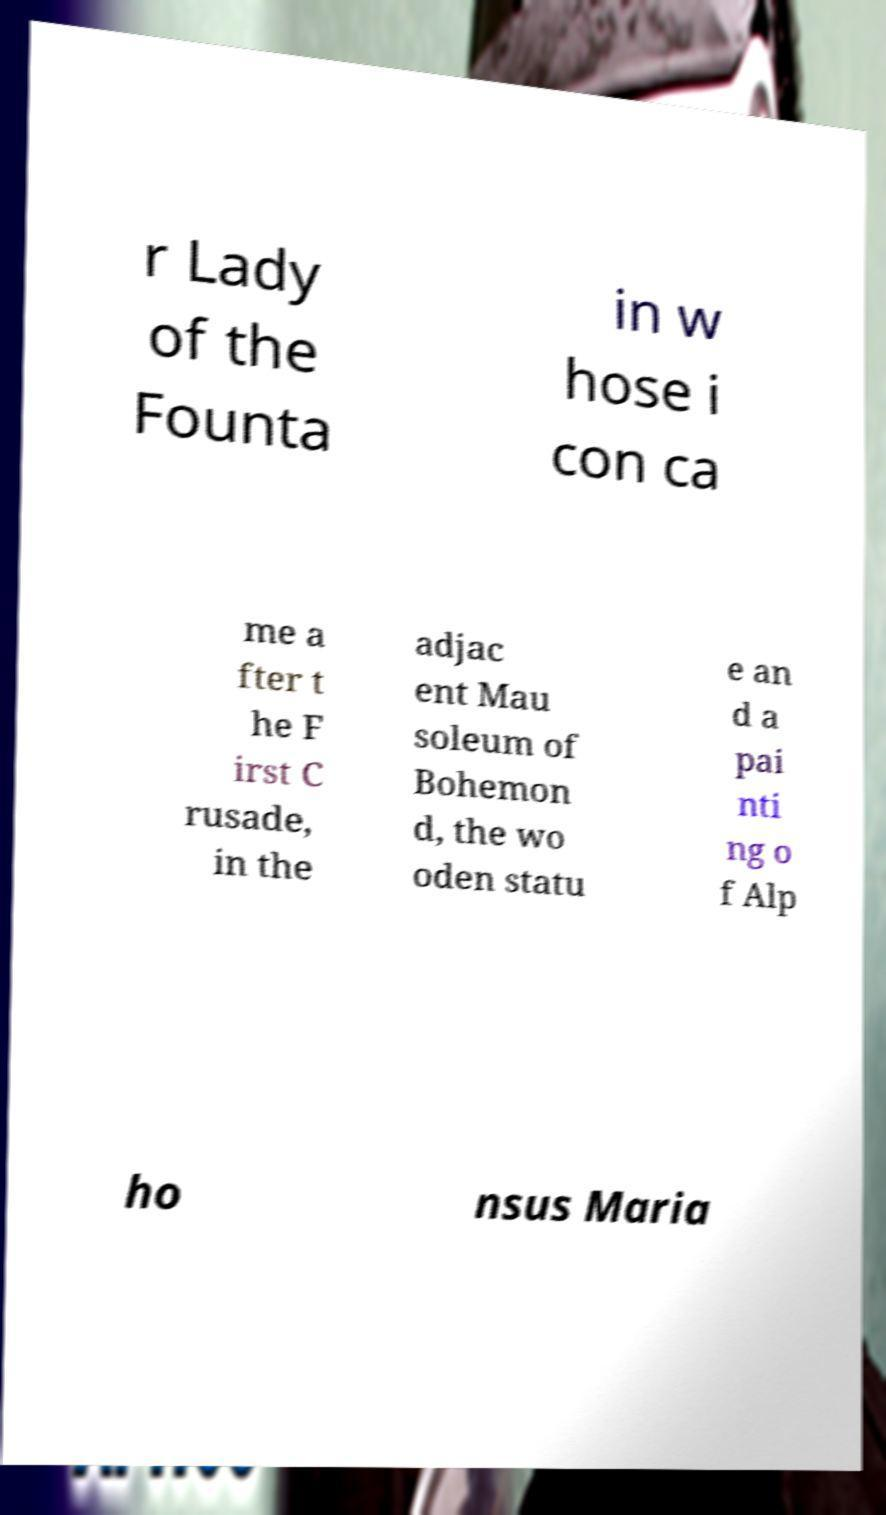Can you accurately transcribe the text from the provided image for me? r Lady of the Founta in w hose i con ca me a fter t he F irst C rusade, in the adjac ent Mau soleum of Bohemon d, the wo oden statu e an d a pai nti ng o f Alp ho nsus Maria 